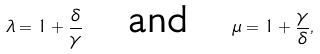<formula> <loc_0><loc_0><loc_500><loc_500>\lambda = 1 + \frac { \delta } { \gamma } \quad \text {and} \quad \mu = 1 + \frac { \gamma } { \delta } ,</formula> 